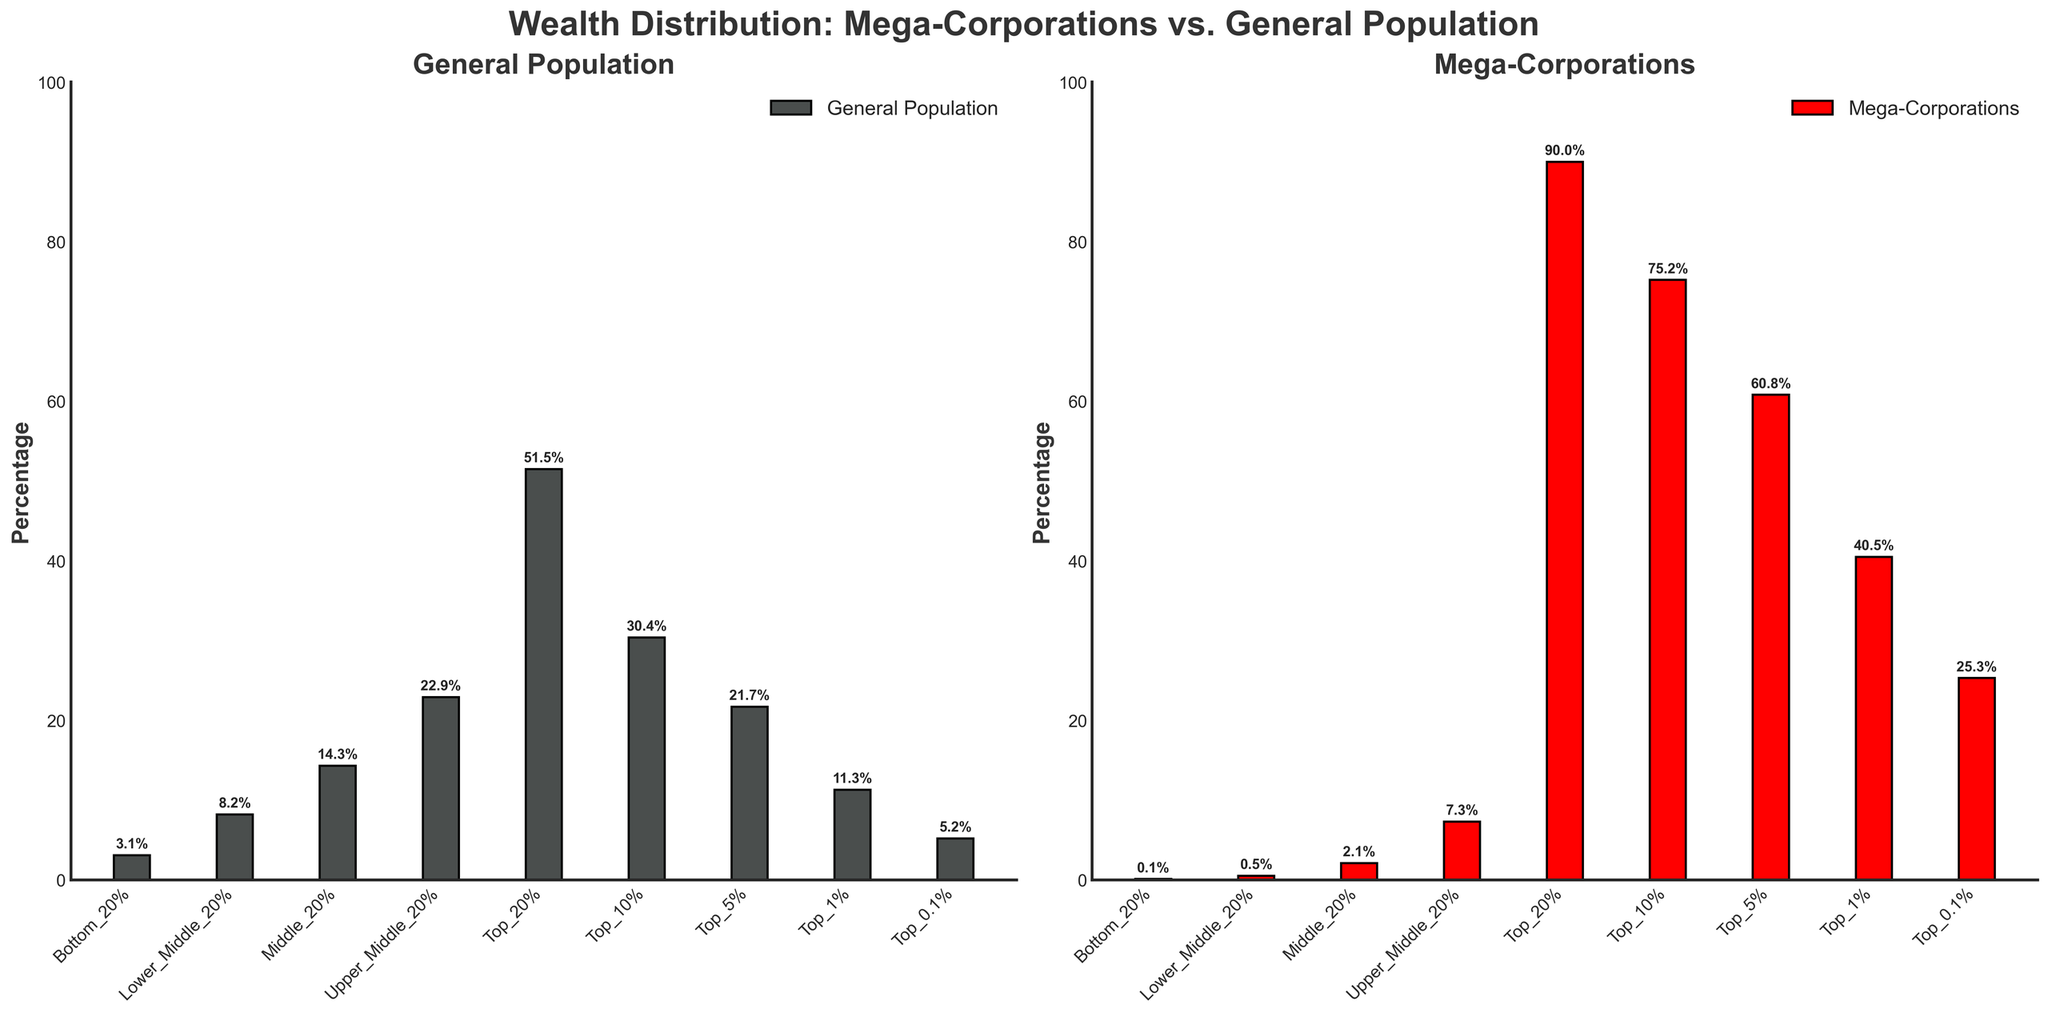Which income bracket has the highest percentage in the Mega-Corporations subplot? Look at the bar heights in the Mega-Corporations subplot. The bar corresponding to the Top 20% income bracket is the tallest.
Answer: Top 20% Which income bracket has the lowest percentage in both the General Population and Mega-Corporations subplots? Identify the shortest bars in both subplots. For both plots, the Bottom 20% income bracket has the shortest bar.
Answer: Bottom 20% How much higher is the percentage of wealth in the Top 10% compared to the Top 1% in the Mega-Corporations subplot? Find the heights of the bars for the Top 10% and Top 1% in the Mega-Corporations subplot and calculate the difference. The Top 10% is at 75.2%, and the Top 1% is at 40.5%. So, 75.2% - 40.5% = 34.7%.
Answer: 34.7% In the General Population subplot, what is the combined percentage of wealth for the Bottom 20% and Lower Middle 20% income brackets? Add the percentages for the Bottom 20% (3.1%) and Lower Middle 20% (8.2%) in the General Population subplot. 3.1% + 8.2% = 11.3%.
Answer: 11.3% Compare the percentage of wealth in the Middle 20% between the General Population and Mega-Corporations subplots. Which one is greater? Look at the bar heights for the Middle 20% in both subplots. In the General Population, it is 14.3%, and in Mega-Corporations, it is 2.1%. 14.3% is greater than 2.1%.
Answer: General Population What percentage of wealth does the Top 0.1% hold in the Mega-Corporations subplot compared to the Top 1% in the General Population subplot? Identify the bar heights for the Top 0.1% in Mega-Corporations (25.3%) and for the Top 1% in General Population (11.3%). Compare the values.
Answer: Top 0.1% in Mega-Corporations Calculate the average percentage of wealth for the Top 5%, Top 1%, and Top 0.1% in the Mega-Corporations subplot. Find the values for the Top 5% (60.8%), Top 1% (40.5%), and Top 0.1% (25.3%) in the Mega-Corporations subplot. Calculate the average: (60.8% + 40.5% + 25.3%)/3 = 42.2%.
Answer: 42.2% Which subplot, General Population or Mega-Corporations, has more evenly distributed wealth among the income brackets? Assess the bar heights across all income brackets in both subplots. The General Population subplot shows more variation within similar ranges, indicating more even distribution compared to the Mega-Corporations subplot where the Top 20% hold a majority of the wealth.
Answer: General Population 